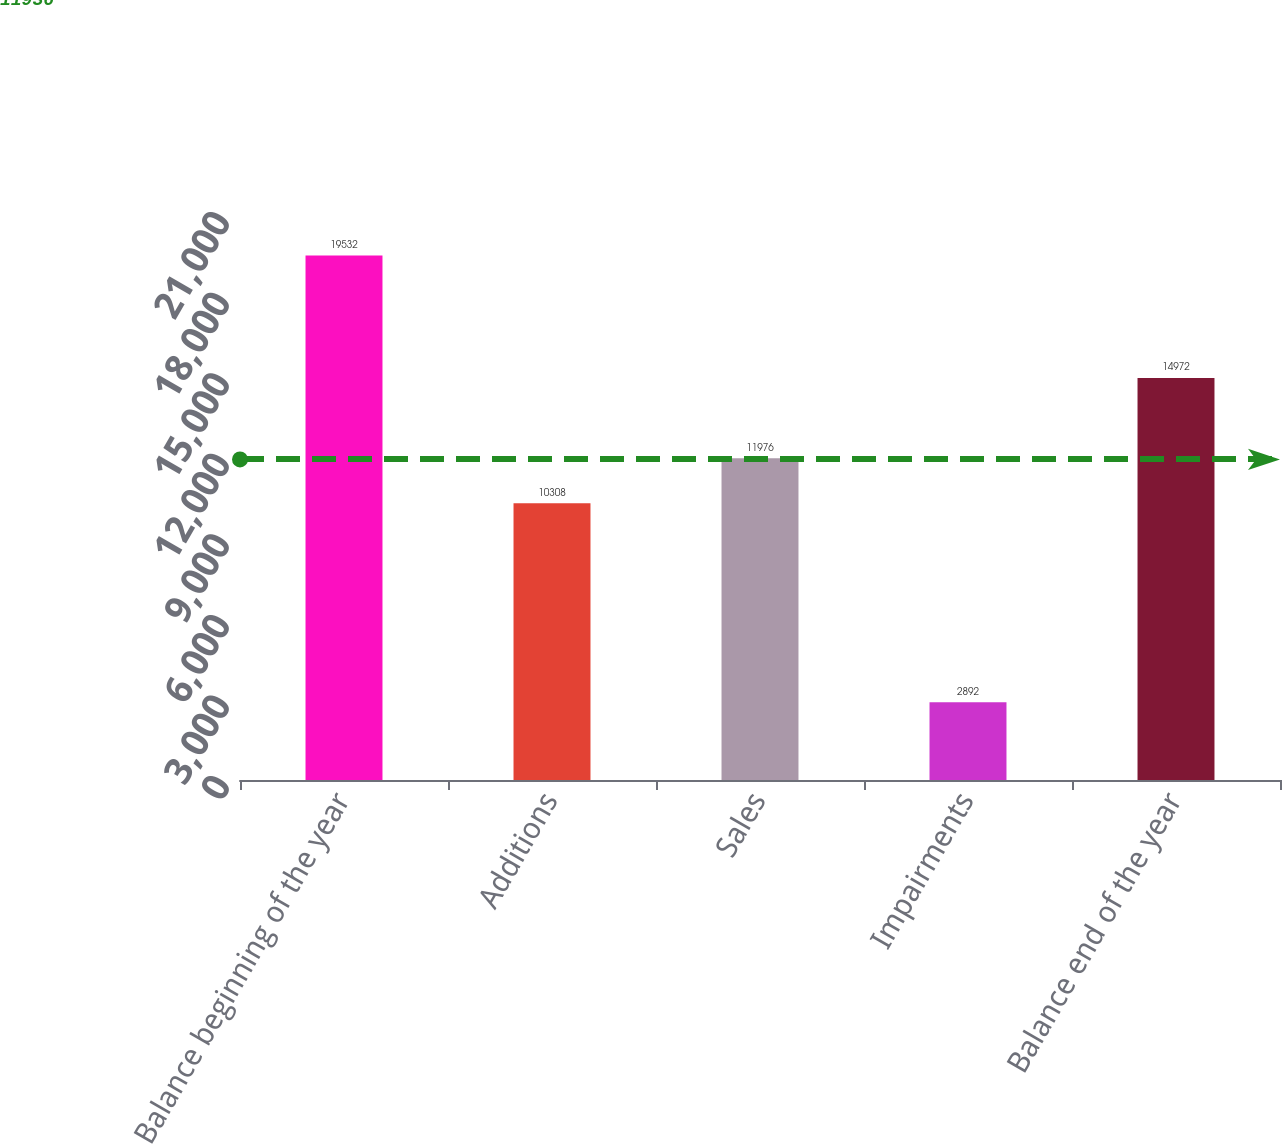<chart> <loc_0><loc_0><loc_500><loc_500><bar_chart><fcel>Balance beginning of the year<fcel>Additions<fcel>Sales<fcel>Impairments<fcel>Balance end of the year<nl><fcel>19532<fcel>10308<fcel>11976<fcel>2892<fcel>14972<nl></chart> 